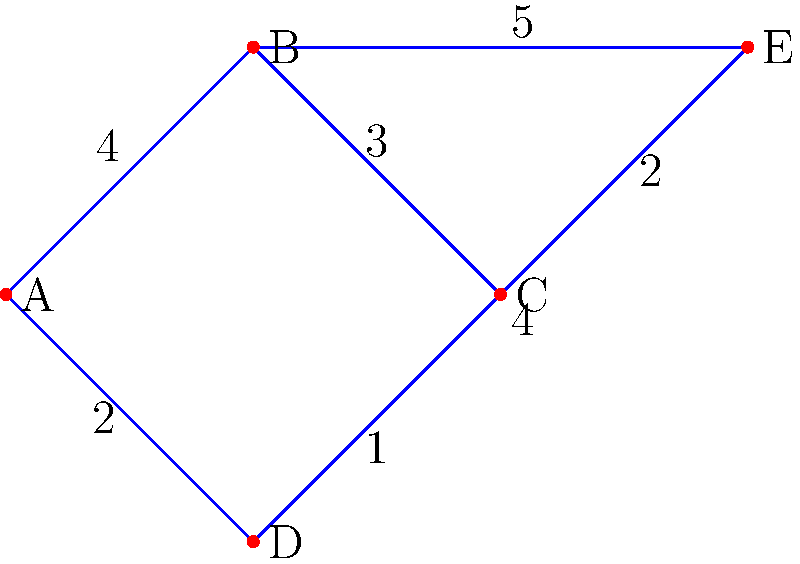As a young forward looking to improve your game, you've been given a weighted graph representing player statistics and connections. The vertices represent different players, and the edge weights indicate the strength of their on-field chemistry. Your task is to determine the minimum spanning tree of this graph, which will help identify the most efficient way to connect all players with the strongest overall chemistry. What is the total weight of the minimum spanning tree? To find the minimum spanning tree (MST) of this graph, we'll use Kruskal's algorithm:

1. Sort all edges by weight in ascending order:
   (C-D, 1), (A-D, 2), (C-E, 2), (B-C, 3), (A-B, 4), (D-E, 4), (B-E, 5)

2. Start with an empty MST and add edges in order, skipping those that would create a cycle:

   a) Add C-D (weight 1)
   b) Add A-D (weight 2)
   c) Add C-E (weight 2)
   d) Add B-C (weight 3)

3. At this point, we have connected all vertices without creating any cycles, so we stop.

4. The MST consists of edges: C-D, A-D, C-E, and B-C.

5. Calculate the total weight of the MST:
   $1 + 2 + 2 + 3 = 8$

Therefore, the total weight of the minimum spanning tree is 8.
Answer: 8 